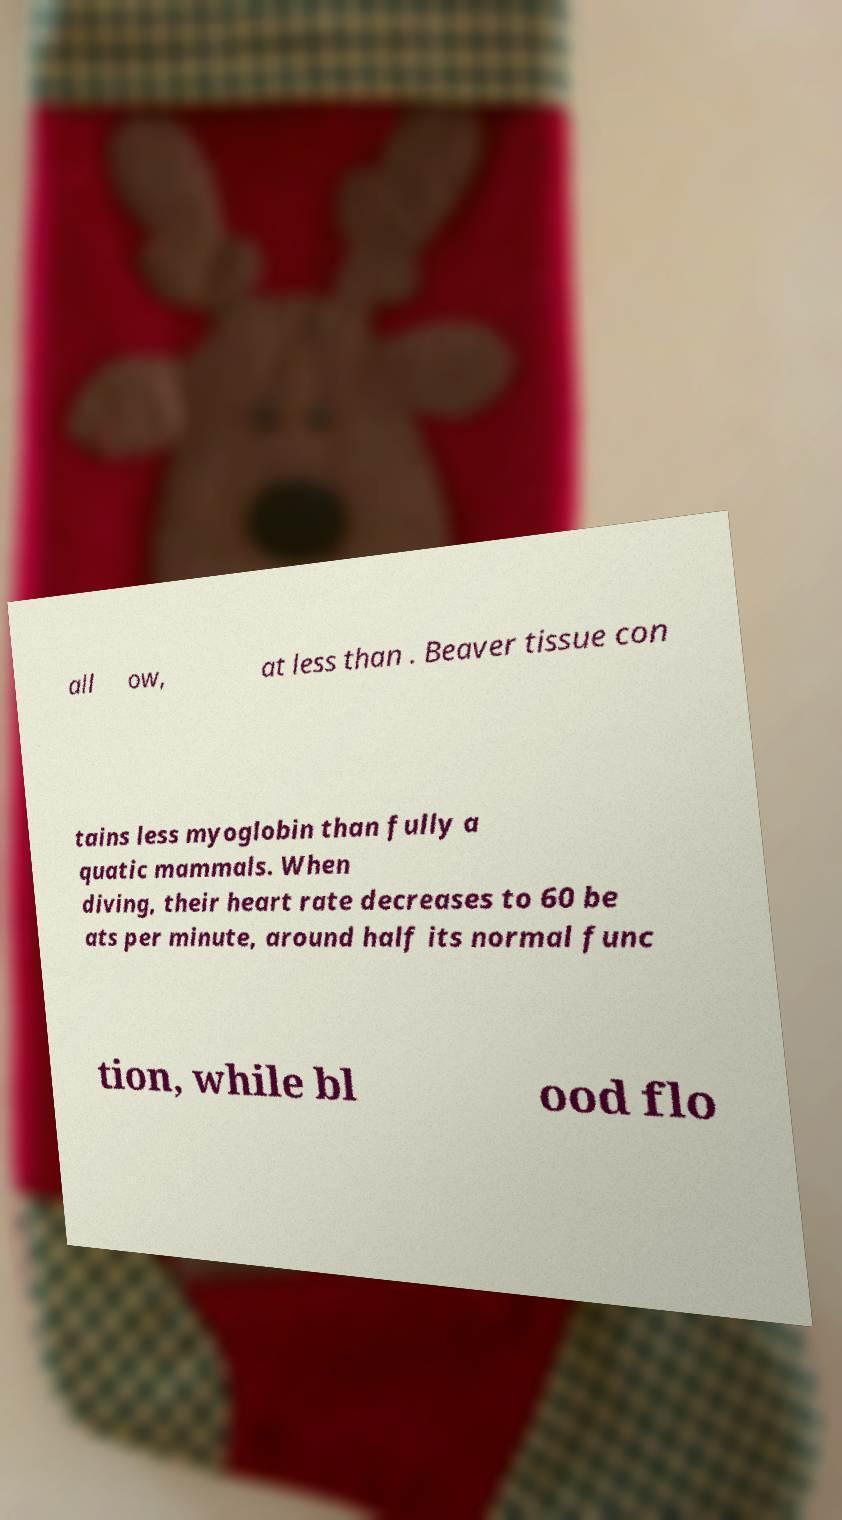Please read and relay the text visible in this image. What does it say? all ow, at less than . Beaver tissue con tains less myoglobin than fully a quatic mammals. When diving, their heart rate decreases to 60 be ats per minute, around half its normal func tion, while bl ood flo 